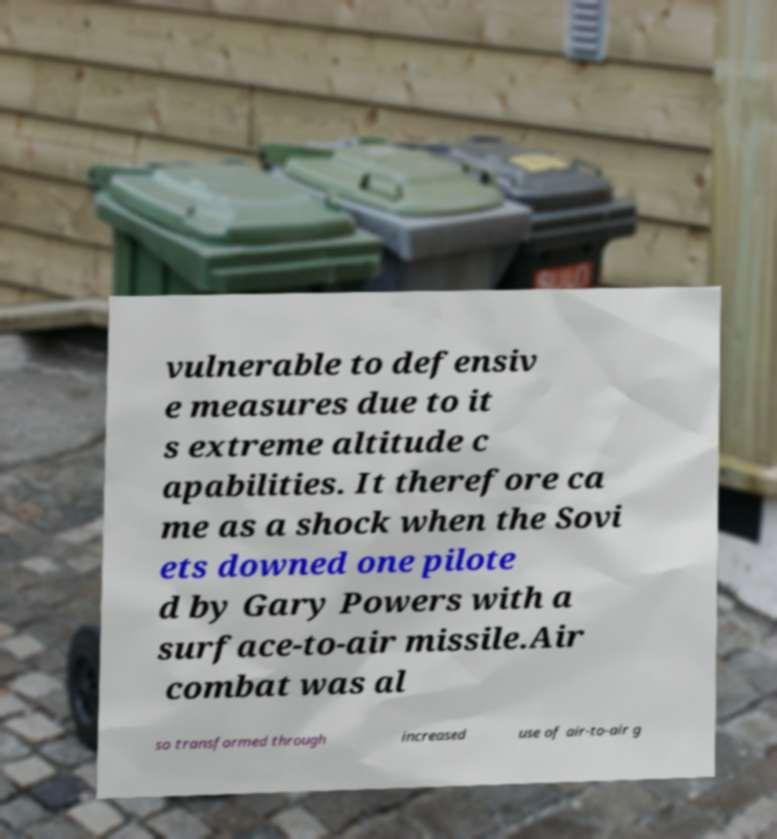Could you extract and type out the text from this image? vulnerable to defensiv e measures due to it s extreme altitude c apabilities. It therefore ca me as a shock when the Sovi ets downed one pilote d by Gary Powers with a surface-to-air missile.Air combat was al so transformed through increased use of air-to-air g 